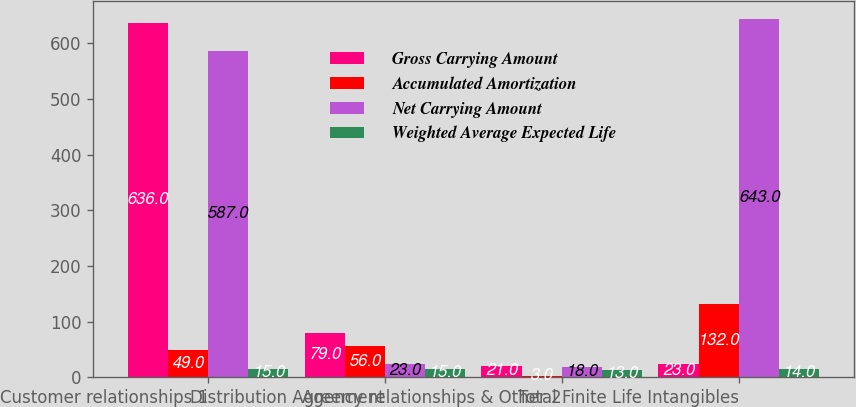Convert chart to OTSL. <chart><loc_0><loc_0><loc_500><loc_500><stacked_bar_chart><ecel><fcel>Customer relationships 1<fcel>Distribution Agreement<fcel>Agency relationships & Other 2<fcel>Total Finite Life Intangibles<nl><fcel>Gross Carrying Amount<fcel>636<fcel>79<fcel>21<fcel>23<nl><fcel>Accumulated Amortization<fcel>49<fcel>56<fcel>3<fcel>132<nl><fcel>Net Carrying Amount<fcel>587<fcel>23<fcel>18<fcel>643<nl><fcel>Weighted Average Expected Life<fcel>15<fcel>15<fcel>13<fcel>14<nl></chart> 